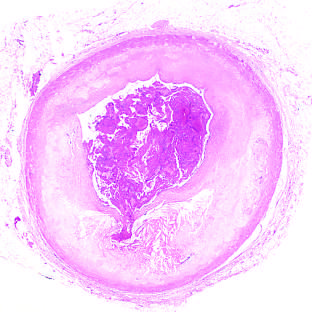s acute coronary throm-bosis superimposed on an atherosclerotic plaque with focal disruption of the fibrous cap, triggering fatal myocardial infarction?
Answer the question using a single word or phrase. Yes 